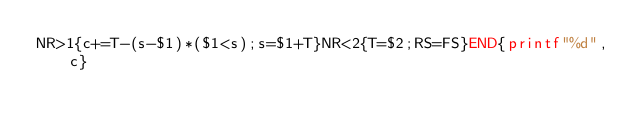Convert code to text. <code><loc_0><loc_0><loc_500><loc_500><_Awk_>NR>1{c+=T-(s-$1)*($1<s);s=$1+T}NR<2{T=$2;RS=FS}END{printf"%d",c}</code> 